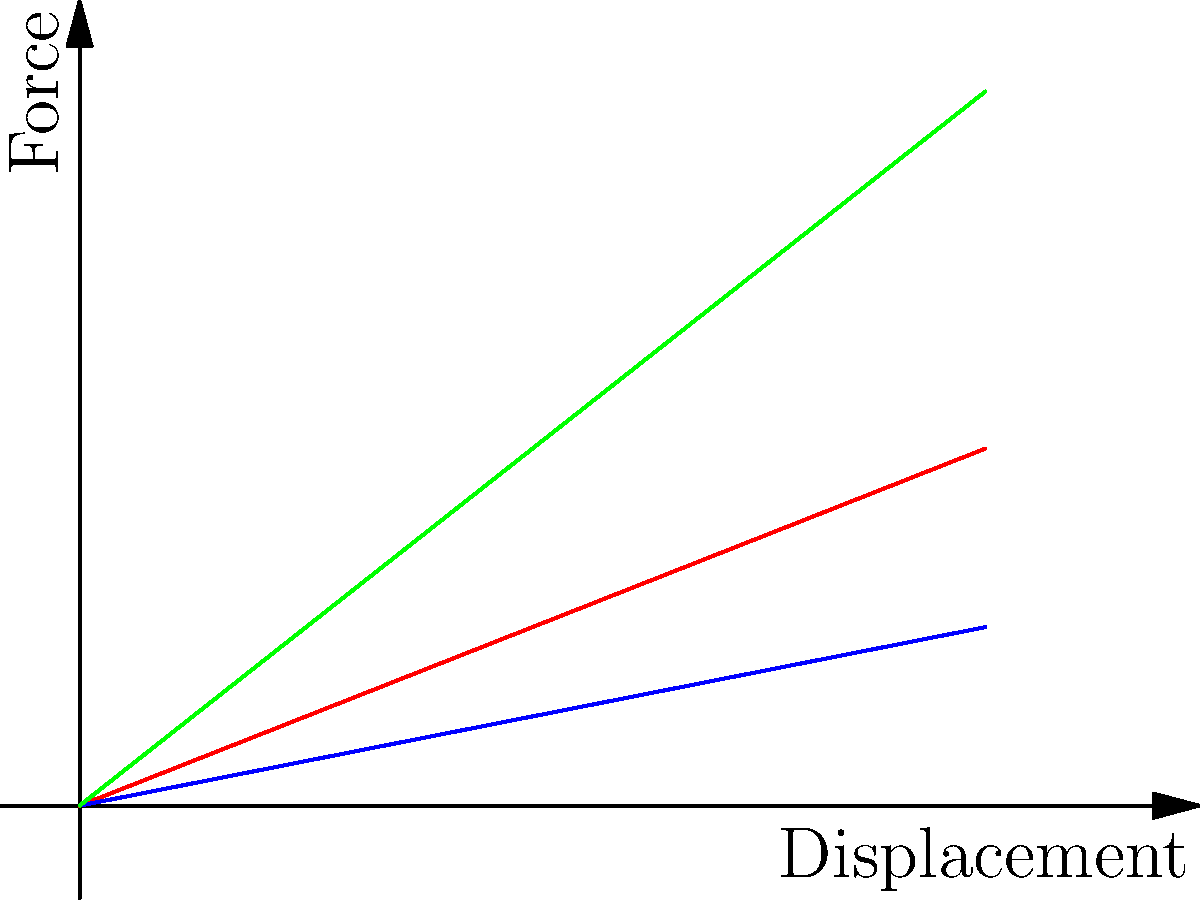In child protection cases, understanding stress and resilience is crucial. Consider the force-displacement graph for different spring designs shown above. Which spring design would best represent a child's ability to bounce back from adversity, and why might this be important in your role as a child protection team manager? To answer this question, let's analyze the graph and relate it to child resilience:

1. The red line represents a linear spring, where force increases proportionally with displacement.
2. The blue line shows a low stiffness spring, where force increases slowly with displacement.
3. The green line indicates a high stiffness spring, where force increases rapidly with displacement.

In the context of child resilience:

1. The linear spring (red) represents consistent resilience, where a child's ability to cope increases steadily with challenges.
2. The low stiffness spring (blue) might represent a child who struggles to cope initially but gradually builds resilience over time.
3. The high stiffness spring (green) could represent a child who shows strong initial resilience but may reach their limit quickly under extreme stress.

As a child protection team manager, the most desirable model would be the linear spring (red line). This represents a child who:

- Demonstrates consistent resilience across various levels of adversity
- Has a predictable response to challenges
- Shows a balanced ability to cope with increasing stress

Understanding this model is important in your role because:

1. It helps in assessing a child's current resilience level
2. It guides the development of appropriate support strategies
3. It aids in predicting how a child might respond to different interventions
4. It assists in identifying children who may need additional support to build resilience

By recognizing these patterns, you can better guide your team in providing tailored support and interventions to help children develop and maintain healthy coping mechanisms in the face of adversity.
Answer: Linear spring model (red line), representing consistent resilience across varying levels of adversity. 